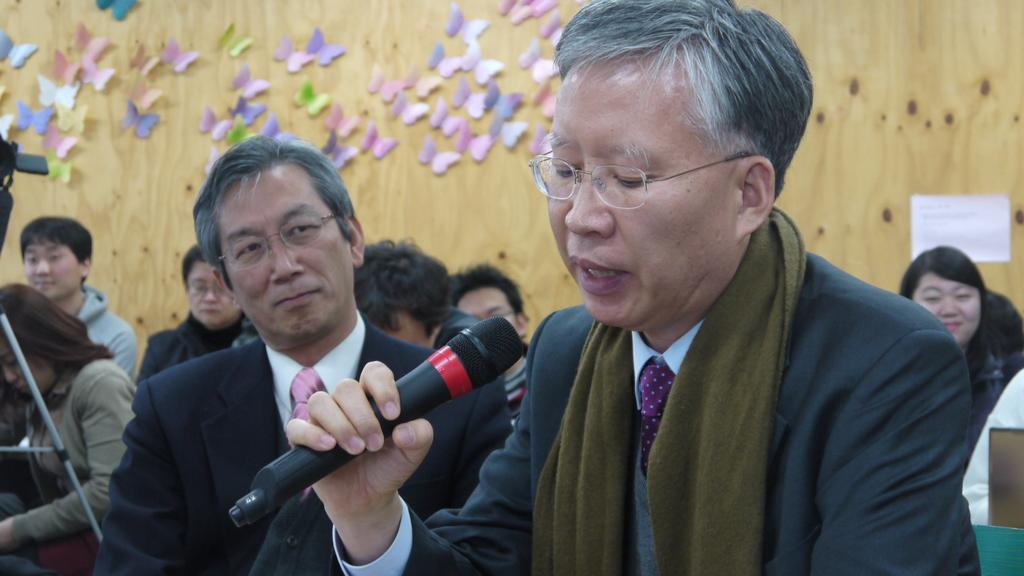How many people are in the image? There are two men in the image. What is one of the men doing in the image? One of the men is speaking into a microphone. How is the other man in the image interacting with the man with the microphone? The other man is looking at the man with the microphone. What type of watch is the man adjusting in the image? There is no watch present in the image, and no adjustments are being made by either man. 